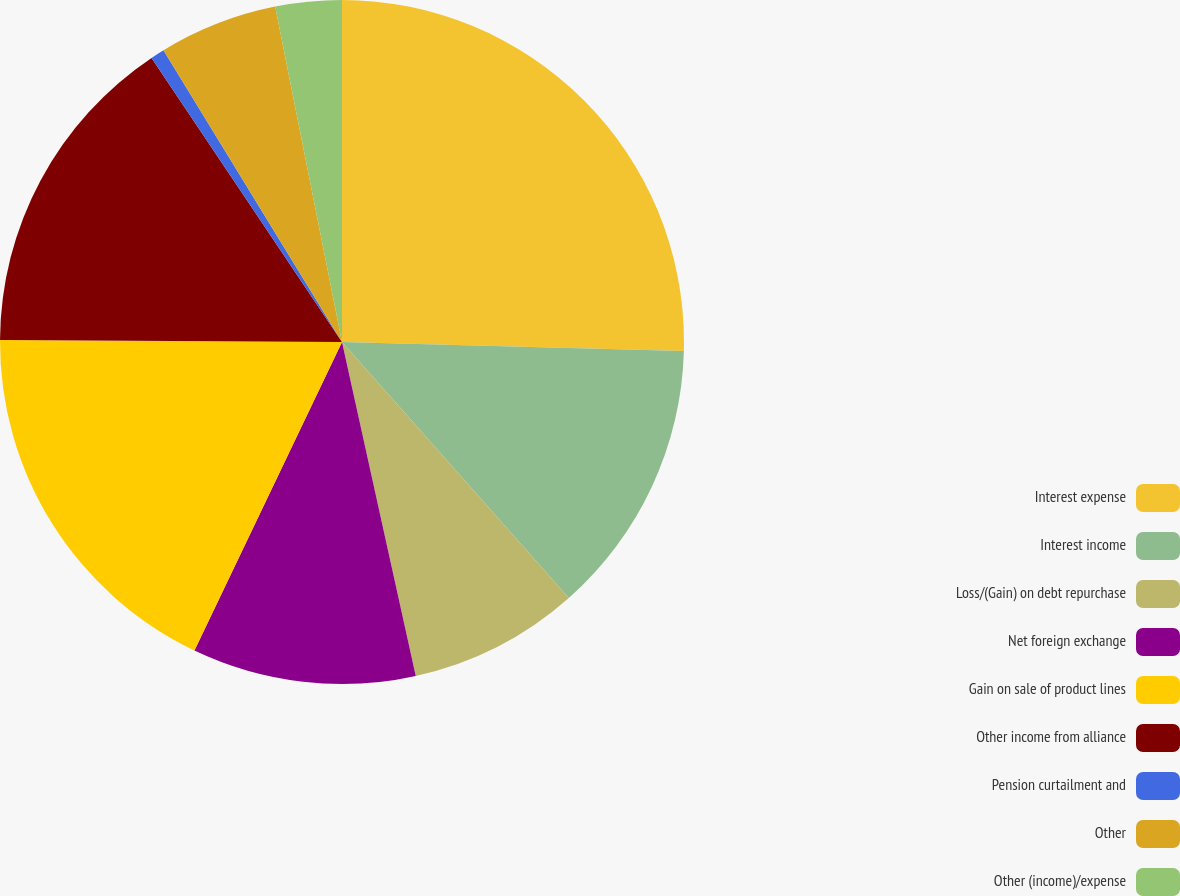Convert chart to OTSL. <chart><loc_0><loc_0><loc_500><loc_500><pie_chart><fcel>Interest expense<fcel>Interest income<fcel>Loss/(Gain) on debt repurchase<fcel>Net foreign exchange<fcel>Gain on sale of product lines<fcel>Other income from alliance<fcel>Pension curtailment and<fcel>Other<fcel>Other (income)/expense<nl><fcel>25.42%<fcel>13.04%<fcel>8.08%<fcel>10.56%<fcel>17.99%<fcel>15.51%<fcel>0.66%<fcel>5.61%<fcel>3.13%<nl></chart> 